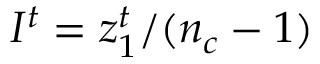Convert formula to latex. <formula><loc_0><loc_0><loc_500><loc_500>I ^ { t } = z _ { 1 } ^ { t } / ( n _ { c } - 1 )</formula> 